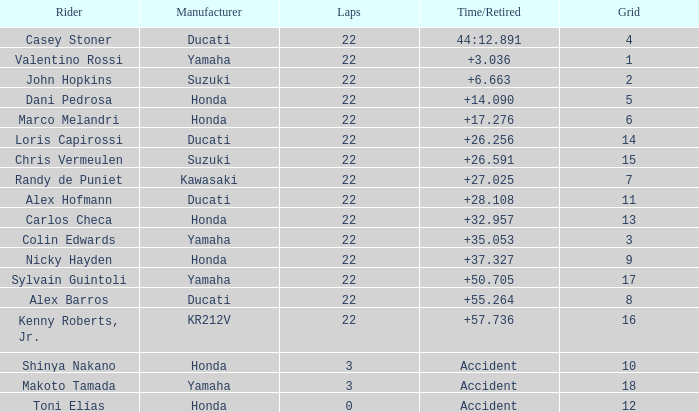What is the typical grid placement for racers who completed fewer than 3 laps? 12.0. 